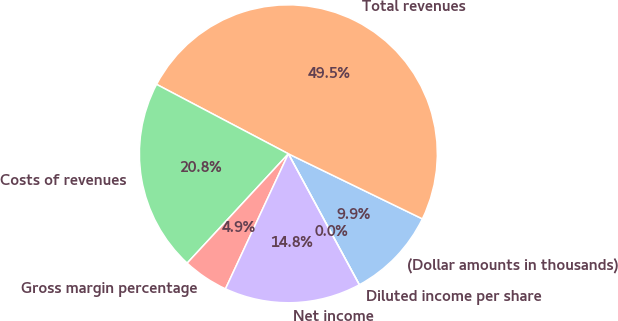Convert chart. <chart><loc_0><loc_0><loc_500><loc_500><pie_chart><fcel>(Dollar amounts in thousands)<fcel>Total revenues<fcel>Costs of revenues<fcel>Gross margin percentage<fcel>Net income<fcel>Diluted income per share<nl><fcel>9.9%<fcel>49.48%<fcel>20.83%<fcel>4.95%<fcel>14.84%<fcel>0.0%<nl></chart> 